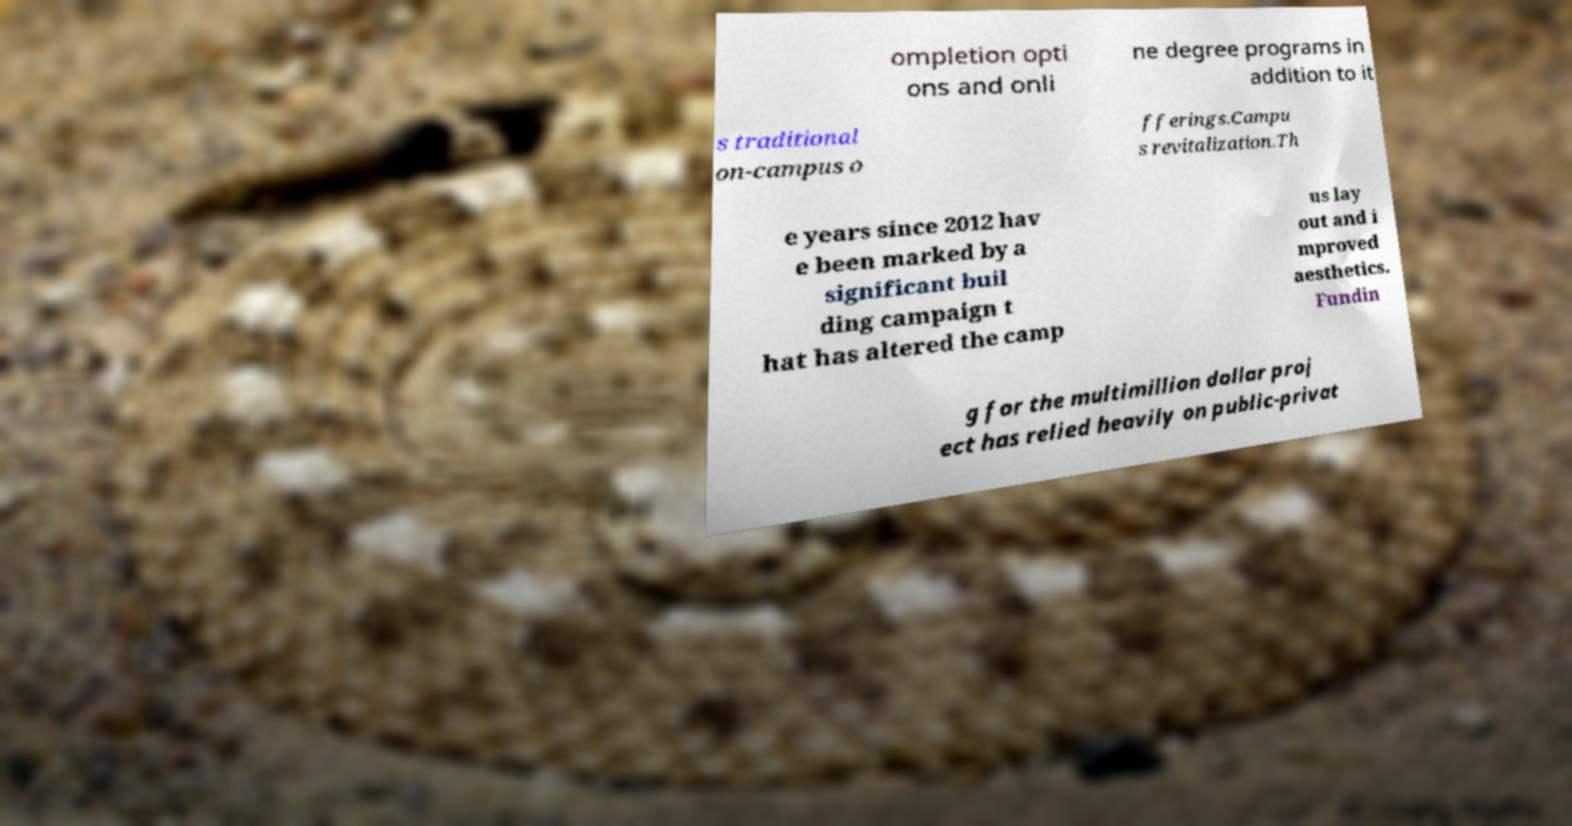Please read and relay the text visible in this image. What does it say? ompletion opti ons and onli ne degree programs in addition to it s traditional on-campus o fferings.Campu s revitalization.Th e years since 2012 hav e been marked by a significant buil ding campaign t hat has altered the camp us lay out and i mproved aesthetics. Fundin g for the multimillion dollar proj ect has relied heavily on public-privat 